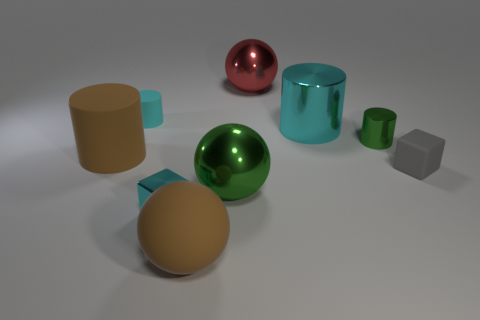The small cyan object that is the same material as the green cylinder is what shape?
Your response must be concise. Cube. Do the green object on the right side of the large cyan shiny cylinder and the big cyan shiny thing have the same shape?
Offer a very short reply. Yes. The brown rubber object on the left side of the large brown matte sphere has what shape?
Keep it short and to the point. Cylinder. There is a tiny metal thing that is the same color as the tiny matte cylinder; what shape is it?
Your response must be concise. Cube. What number of red balls are the same size as the cyan matte object?
Give a very brief answer. 0. The small shiny cylinder is what color?
Keep it short and to the point. Green. Does the shiny cube have the same color as the large cylinder that is to the left of the red metallic sphere?
Offer a terse response. No. There is a block that is made of the same material as the red thing; what is its size?
Make the answer very short. Small. Is there a small rubber thing of the same color as the big metal cylinder?
Your response must be concise. Yes. How many things are tiny cyan things in front of the red object or big brown metallic spheres?
Give a very brief answer. 2. 